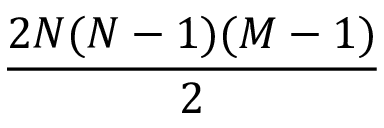<formula> <loc_0><loc_0><loc_500><loc_500>\frac { 2 N ( N - 1 ) ( M - 1 ) } { 2 }</formula> 